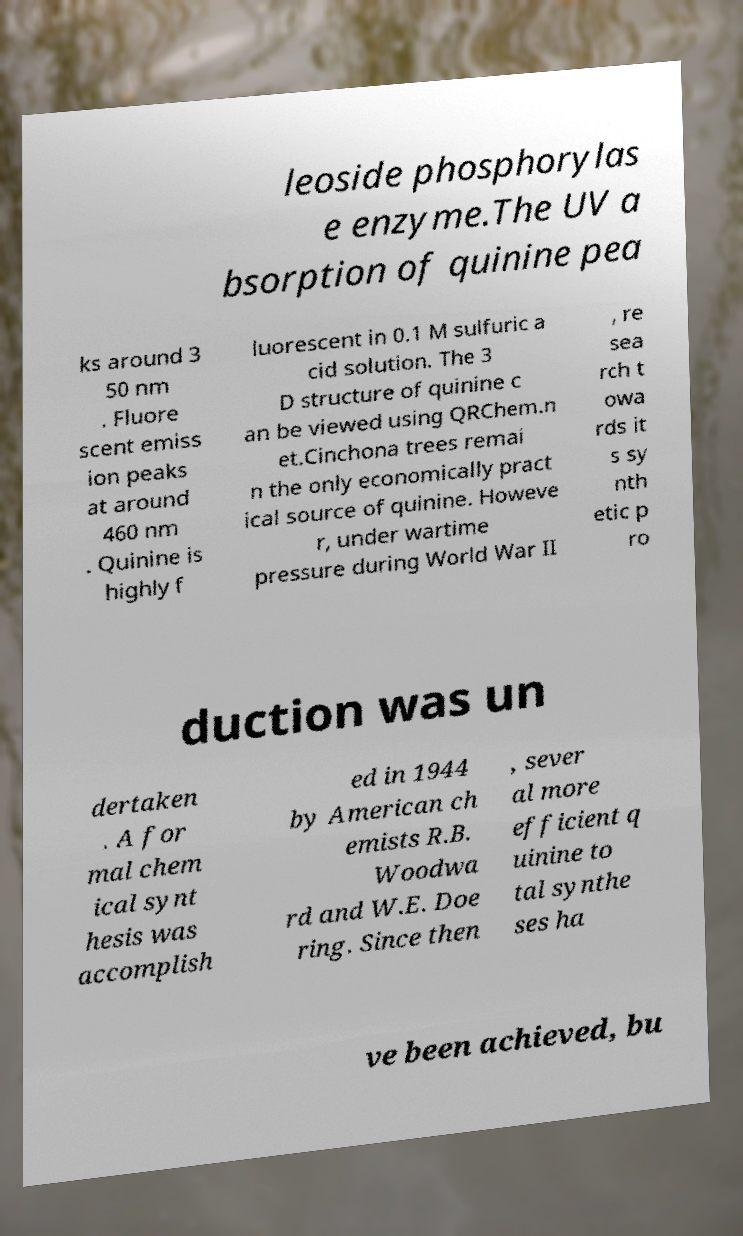Could you extract and type out the text from this image? leoside phosphorylas e enzyme.The UV a bsorption of quinine pea ks around 3 50 nm . Fluore scent emiss ion peaks at around 460 nm . Quinine is highly f luorescent in 0.1 M sulfuric a cid solution. The 3 D structure of quinine c an be viewed using QRChem.n et.Cinchona trees remai n the only economically pract ical source of quinine. Howeve r, under wartime pressure during World War II , re sea rch t owa rds it s sy nth etic p ro duction was un dertaken . A for mal chem ical synt hesis was accomplish ed in 1944 by American ch emists R.B. Woodwa rd and W.E. Doe ring. Since then , sever al more efficient q uinine to tal synthe ses ha ve been achieved, bu 